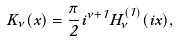Convert formula to latex. <formula><loc_0><loc_0><loc_500><loc_500>K _ { \nu } ( x ) = \frac { \pi } { 2 } i ^ { \nu + 1 } H _ { \nu } ^ { ( 1 ) } ( i x ) ,</formula> 